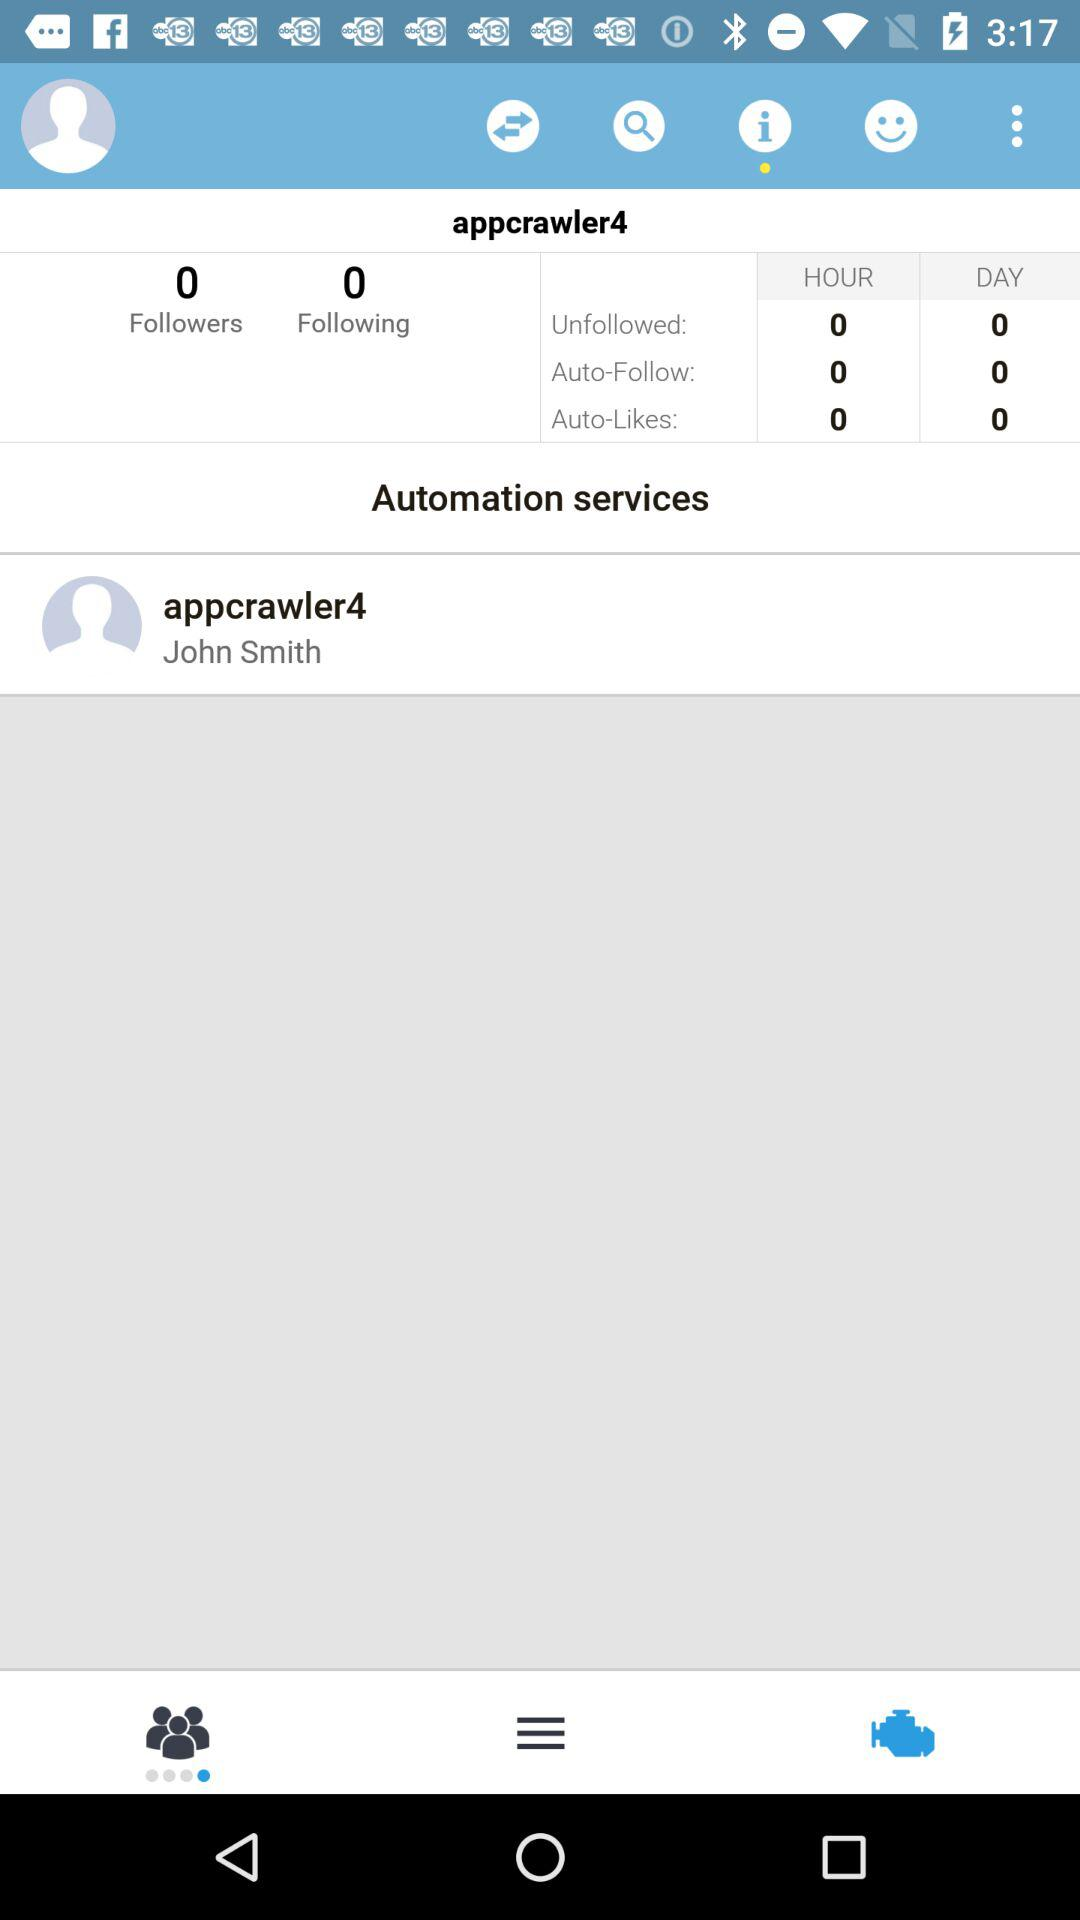What is the user name? The user name is appcrawler4. 